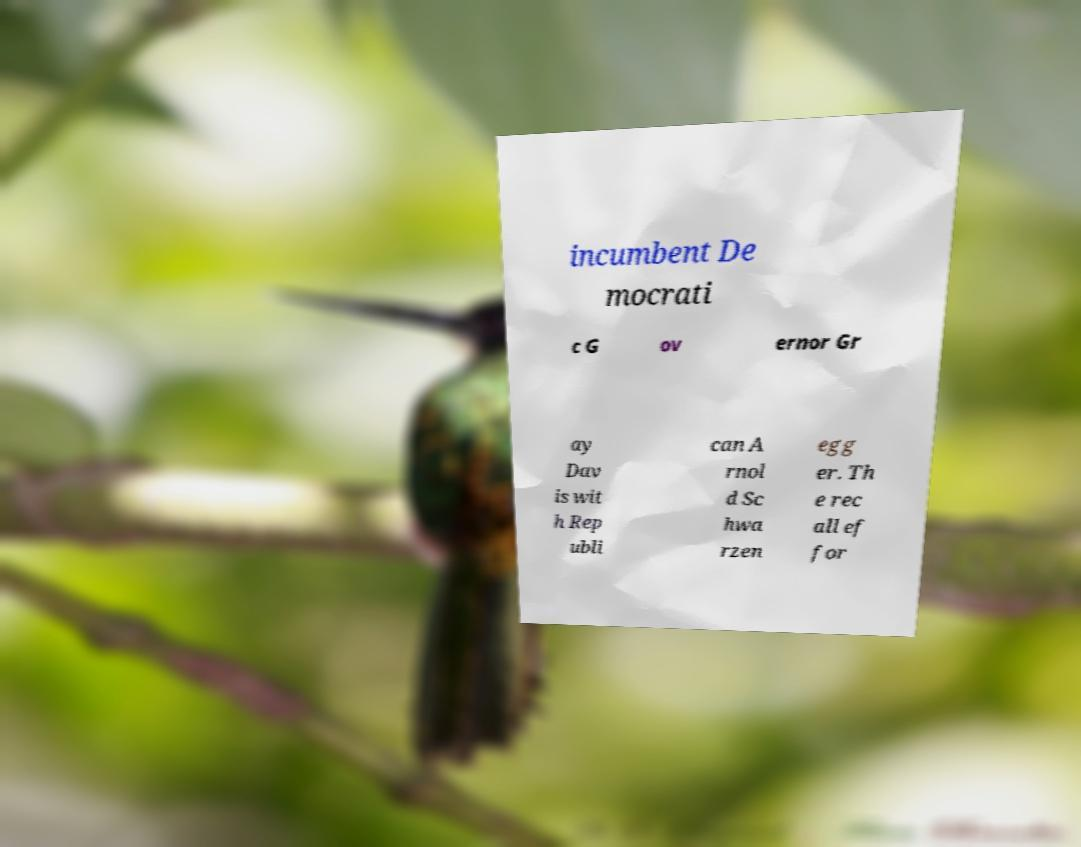Can you read and provide the text displayed in the image?This photo seems to have some interesting text. Can you extract and type it out for me? incumbent De mocrati c G ov ernor Gr ay Dav is wit h Rep ubli can A rnol d Sc hwa rzen egg er. Th e rec all ef for 